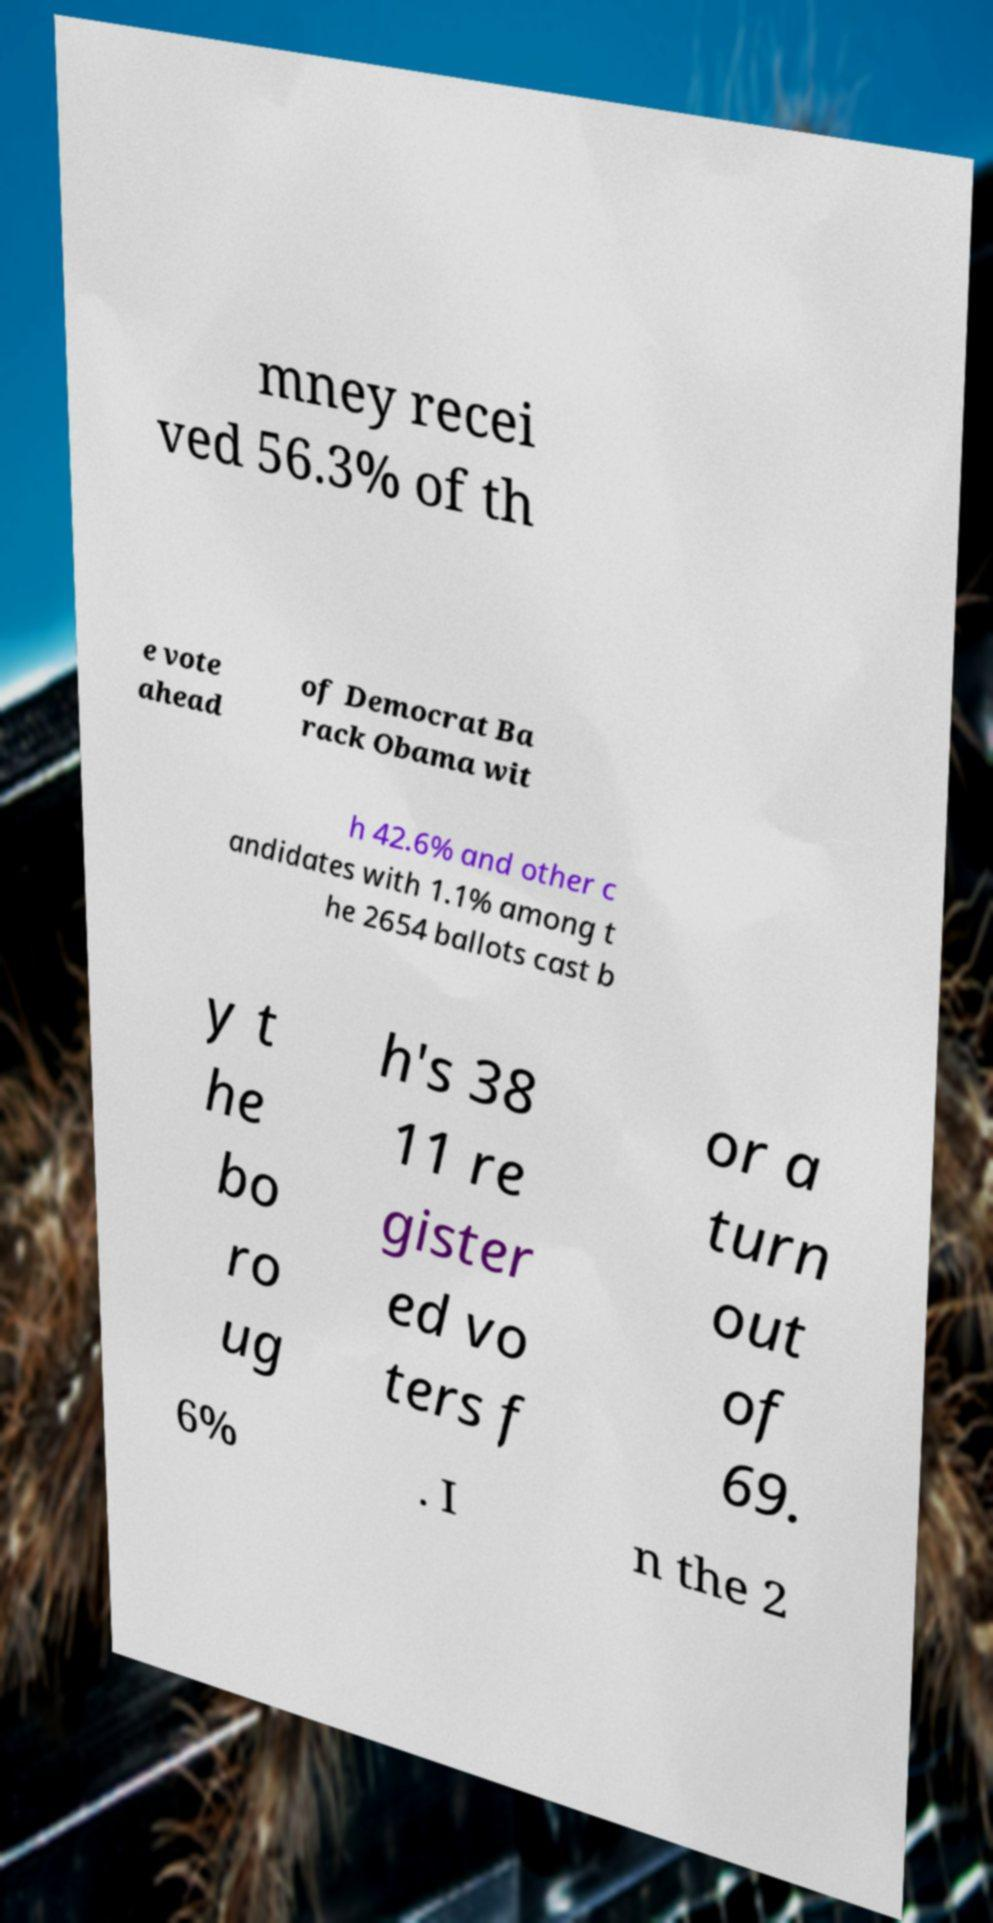Please identify and transcribe the text found in this image. mney recei ved 56.3% of th e vote ahead of Democrat Ba rack Obama wit h 42.6% and other c andidates with 1.1% among t he 2654 ballots cast b y t he bo ro ug h's 38 11 re gister ed vo ters f or a turn out of 69. 6% . I n the 2 